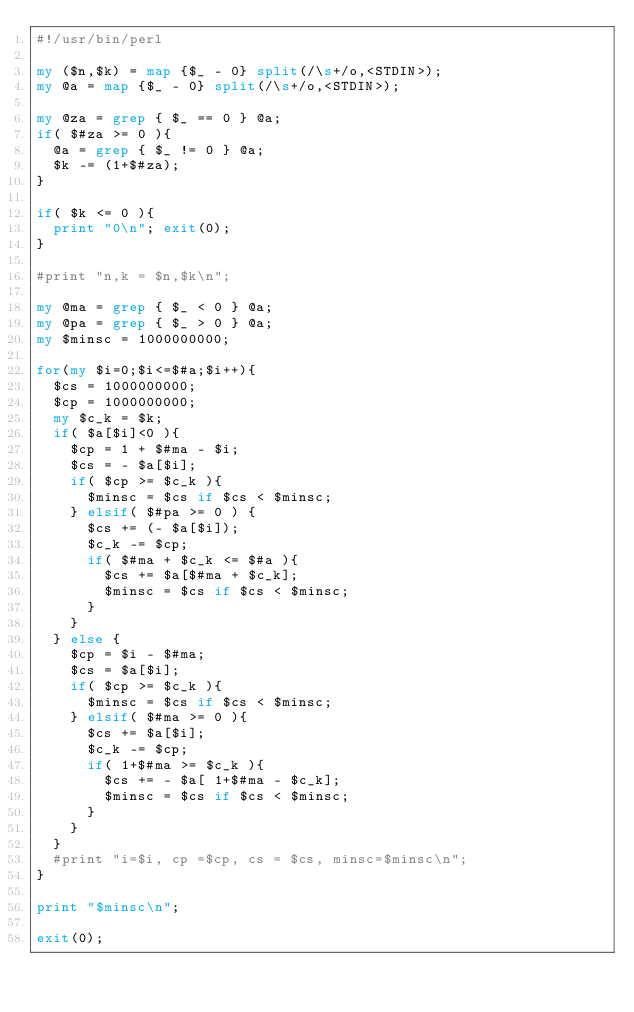Convert code to text. <code><loc_0><loc_0><loc_500><loc_500><_Perl_>#!/usr/bin/perl

my ($n,$k) = map {$_ - 0} split(/\s+/o,<STDIN>);
my @a = map {$_ - 0} split(/\s+/o,<STDIN>);

my @za = grep { $_ == 0 } @a;
if( $#za >= 0 ){
  @a = grep { $_ != 0 } @a;
  $k -= (1+$#za);
}

if( $k <= 0 ){
  print "0\n"; exit(0);
}

#print "n,k = $n,$k\n";

my @ma = grep { $_ < 0 } @a;
my @pa = grep { $_ > 0 } @a;
my $minsc = 1000000000;

for(my $i=0;$i<=$#a;$i++){
  $cs = 1000000000;
  $cp = 1000000000;
  my $c_k = $k;
  if( $a[$i]<0 ){
    $cp = 1 + $#ma - $i;
    $cs = - $a[$i];
    if( $cp >= $c_k ){
      $minsc = $cs if $cs < $minsc;
    } elsif( $#pa >= 0 ) {
      $cs += (- $a[$i]);
      $c_k -= $cp;
      if( $#ma + $c_k <= $#a ){
        $cs += $a[$#ma + $c_k];
        $minsc = $cs if $cs < $minsc;
      }
    }
  } else {
    $cp = $i - $#ma;
    $cs = $a[$i];
    if( $cp >= $c_k ){
      $minsc = $cs if $cs < $minsc;
    } elsif( $#ma >= 0 ){
      $cs += $a[$i];
      $c_k -= $cp;
      if( 1+$#ma >= $c_k ){
        $cs += - $a[ 1+$#ma - $c_k];
        $minsc = $cs if $cs < $minsc;
      }
    }
  }
  #print "i=$i, cp =$cp, cs = $cs, minsc=$minsc\n";
}

print "$minsc\n";

exit(0);

</code> 